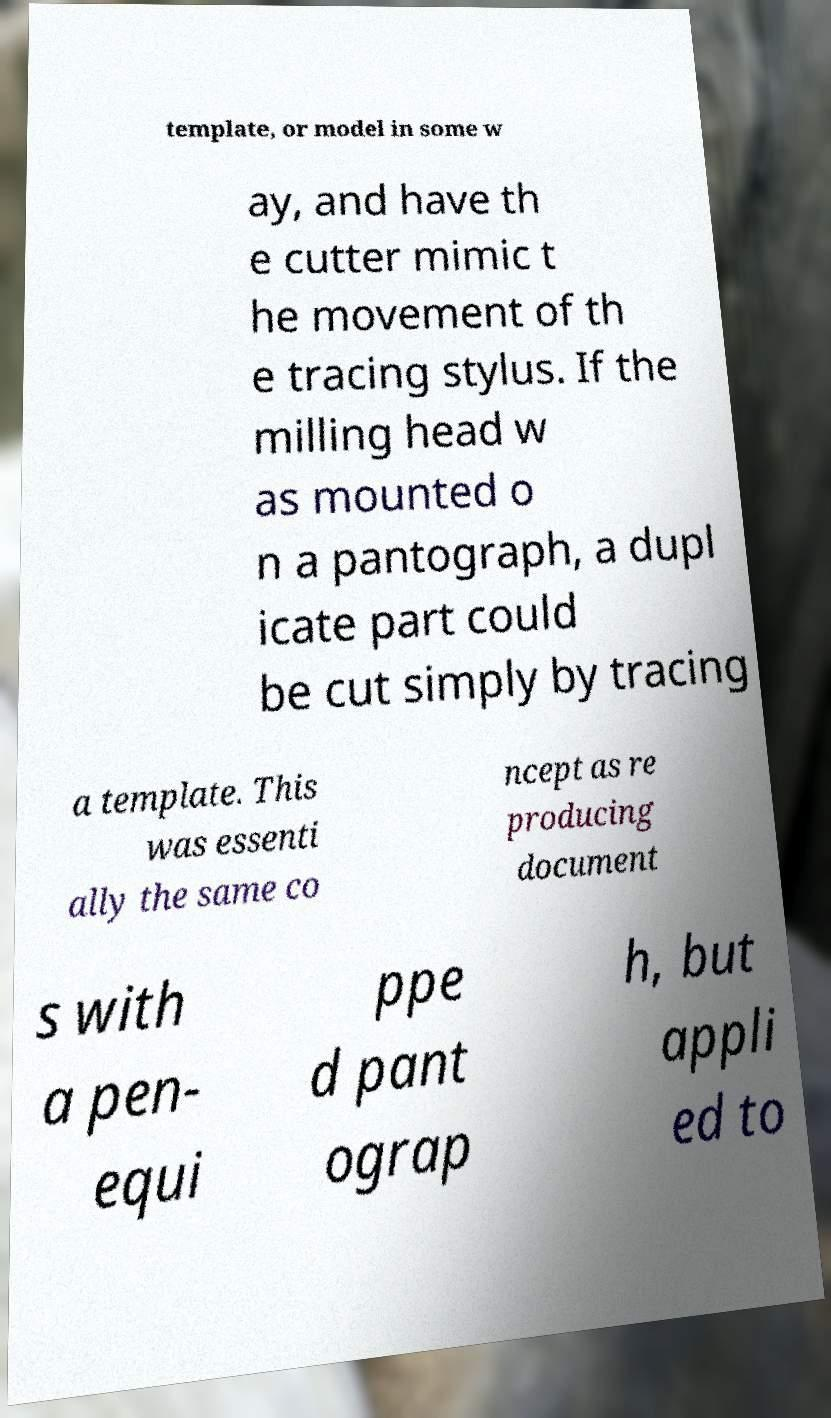For documentation purposes, I need the text within this image transcribed. Could you provide that? template, or model in some w ay, and have th e cutter mimic t he movement of th e tracing stylus. If the milling head w as mounted o n a pantograph, a dupl icate part could be cut simply by tracing a template. This was essenti ally the same co ncept as re producing document s with a pen- equi ppe d pant ograp h, but appli ed to 